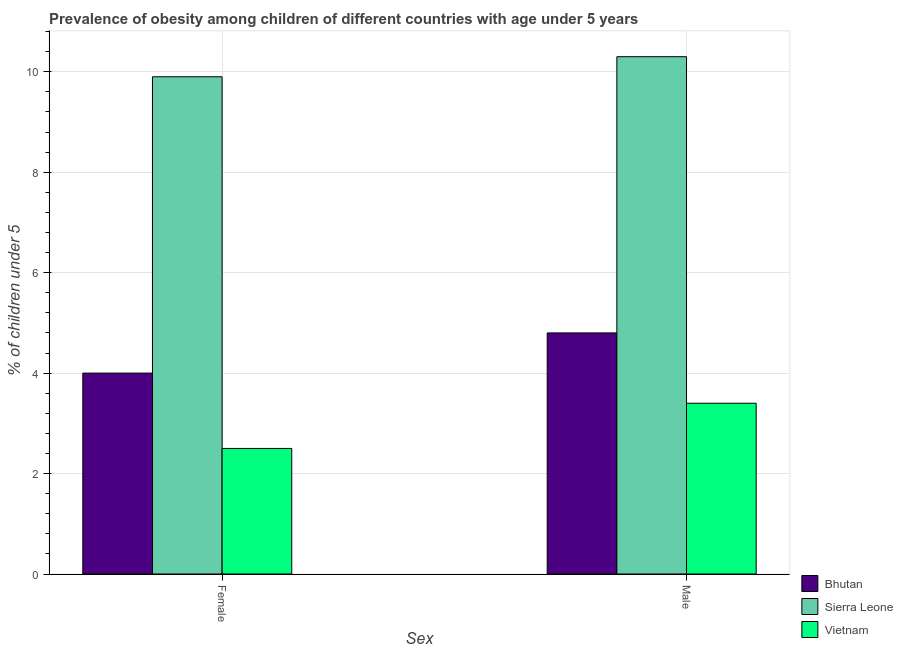How many different coloured bars are there?
Provide a succinct answer. 3. Are the number of bars per tick equal to the number of legend labels?
Offer a very short reply. Yes. What is the label of the 2nd group of bars from the left?
Give a very brief answer. Male. What is the percentage of obese female children in Vietnam?
Ensure brevity in your answer.  2.5. Across all countries, what is the maximum percentage of obese female children?
Make the answer very short. 9.9. Across all countries, what is the minimum percentage of obese male children?
Make the answer very short. 3.4. In which country was the percentage of obese male children maximum?
Keep it short and to the point. Sierra Leone. In which country was the percentage of obese male children minimum?
Provide a short and direct response. Vietnam. What is the total percentage of obese male children in the graph?
Make the answer very short. 18.5. What is the difference between the percentage of obese female children in Vietnam and that in Bhutan?
Provide a short and direct response. -1.5. What is the difference between the percentage of obese male children in Bhutan and the percentage of obese female children in Sierra Leone?
Keep it short and to the point. -5.1. What is the average percentage of obese female children per country?
Ensure brevity in your answer.  5.47. What is the difference between the percentage of obese male children and percentage of obese female children in Vietnam?
Make the answer very short. 0.9. What is the ratio of the percentage of obese male children in Sierra Leone to that in Vietnam?
Your answer should be very brief. 3.03. In how many countries, is the percentage of obese female children greater than the average percentage of obese female children taken over all countries?
Offer a terse response. 1. What does the 3rd bar from the left in Male represents?
Offer a terse response. Vietnam. What does the 1st bar from the right in Male represents?
Provide a short and direct response. Vietnam. How many bars are there?
Provide a short and direct response. 6. Are all the bars in the graph horizontal?
Offer a terse response. No. What is the difference between two consecutive major ticks on the Y-axis?
Provide a succinct answer. 2. Are the values on the major ticks of Y-axis written in scientific E-notation?
Provide a succinct answer. No. Does the graph contain any zero values?
Provide a succinct answer. No. Where does the legend appear in the graph?
Your answer should be very brief. Bottom right. How are the legend labels stacked?
Ensure brevity in your answer.  Vertical. What is the title of the graph?
Provide a succinct answer. Prevalence of obesity among children of different countries with age under 5 years. Does "Cyprus" appear as one of the legend labels in the graph?
Provide a succinct answer. No. What is the label or title of the X-axis?
Give a very brief answer. Sex. What is the label or title of the Y-axis?
Your response must be concise.  % of children under 5. What is the  % of children under 5 in Sierra Leone in Female?
Provide a short and direct response. 9.9. What is the  % of children under 5 of Bhutan in Male?
Ensure brevity in your answer.  4.8. What is the  % of children under 5 of Sierra Leone in Male?
Provide a short and direct response. 10.3. What is the  % of children under 5 in Vietnam in Male?
Your answer should be very brief. 3.4. Across all Sex, what is the maximum  % of children under 5 in Bhutan?
Your response must be concise. 4.8. Across all Sex, what is the maximum  % of children under 5 of Sierra Leone?
Give a very brief answer. 10.3. Across all Sex, what is the maximum  % of children under 5 in Vietnam?
Your response must be concise. 3.4. Across all Sex, what is the minimum  % of children under 5 in Bhutan?
Offer a terse response. 4. Across all Sex, what is the minimum  % of children under 5 of Sierra Leone?
Provide a short and direct response. 9.9. What is the total  % of children under 5 in Bhutan in the graph?
Your answer should be compact. 8.8. What is the total  % of children under 5 of Sierra Leone in the graph?
Your answer should be compact. 20.2. What is the total  % of children under 5 of Vietnam in the graph?
Make the answer very short. 5.9. What is the difference between the  % of children under 5 of Sierra Leone in Female and that in Male?
Your response must be concise. -0.4. What is the difference between the  % of children under 5 in Bhutan in Female and the  % of children under 5 in Sierra Leone in Male?
Provide a succinct answer. -6.3. What is the difference between the  % of children under 5 of Sierra Leone in Female and the  % of children under 5 of Vietnam in Male?
Offer a very short reply. 6.5. What is the average  % of children under 5 of Vietnam per Sex?
Give a very brief answer. 2.95. What is the difference between the  % of children under 5 in Bhutan and  % of children under 5 in Vietnam in Female?
Provide a succinct answer. 1.5. What is the difference between the  % of children under 5 in Bhutan and  % of children under 5 in Vietnam in Male?
Give a very brief answer. 1.4. What is the ratio of the  % of children under 5 in Bhutan in Female to that in Male?
Make the answer very short. 0.83. What is the ratio of the  % of children under 5 of Sierra Leone in Female to that in Male?
Offer a very short reply. 0.96. What is the ratio of the  % of children under 5 in Vietnam in Female to that in Male?
Your answer should be very brief. 0.74. What is the difference between the highest and the second highest  % of children under 5 of Bhutan?
Keep it short and to the point. 0.8. What is the difference between the highest and the second highest  % of children under 5 of Sierra Leone?
Your answer should be compact. 0.4. What is the difference between the highest and the lowest  % of children under 5 in Bhutan?
Make the answer very short. 0.8. What is the difference between the highest and the lowest  % of children under 5 in Vietnam?
Provide a succinct answer. 0.9. 